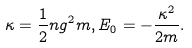Convert formula to latex. <formula><loc_0><loc_0><loc_500><loc_500>\kappa = \frac { 1 } { 2 } n g ^ { 2 } m , E _ { 0 } = - \frac { \kappa ^ { 2 } } { 2 m } .</formula> 